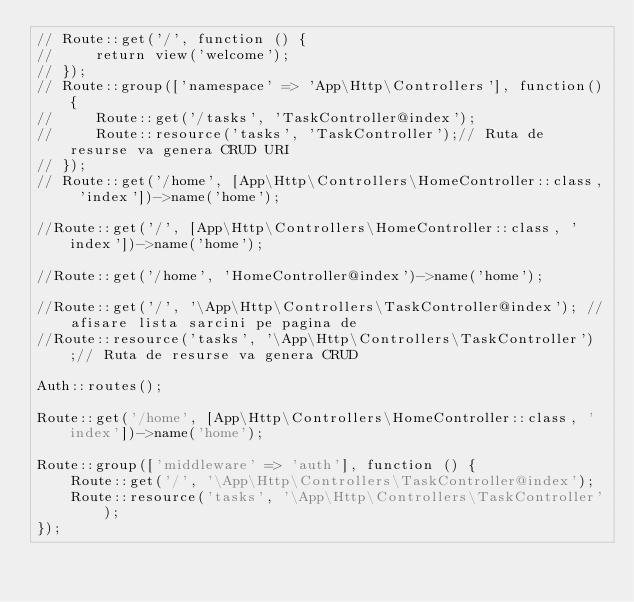<code> <loc_0><loc_0><loc_500><loc_500><_PHP_>// Route::get('/', function () {
//     return view('welcome');
// });
// Route::group(['namespace' => 'App\Http\Controllers'], function(){
//     Route::get('/tasks', 'TaskController@index');
//     Route::resource('tasks', 'TaskController');// Ruta de resurse va genera CRUD URI
// });
// Route::get('/home', [App\Http\Controllers\HomeController::class, 'index'])->name('home');

//Route::get('/', [App\Http\Controllers\HomeController::class, 'index'])->name('home');

//Route::get('/home', 'HomeController@index')->name('home');

//Route::get('/', '\App\Http\Controllers\TaskController@index'); //afisare lista sarcini pe pagina de
//Route::resource('tasks', '\App\Http\Controllers\TaskController');// Ruta de resurse va genera CRUD

Auth::routes();

Route::get('/home', [App\Http\Controllers\HomeController::class, 'index'])->name('home');

Route::group(['middleware' => 'auth'], function () {
    Route::get('/', '\App\Http\Controllers\TaskController@index');
    Route::resource('tasks', '\App\Http\Controllers\TaskController');
});
</code> 